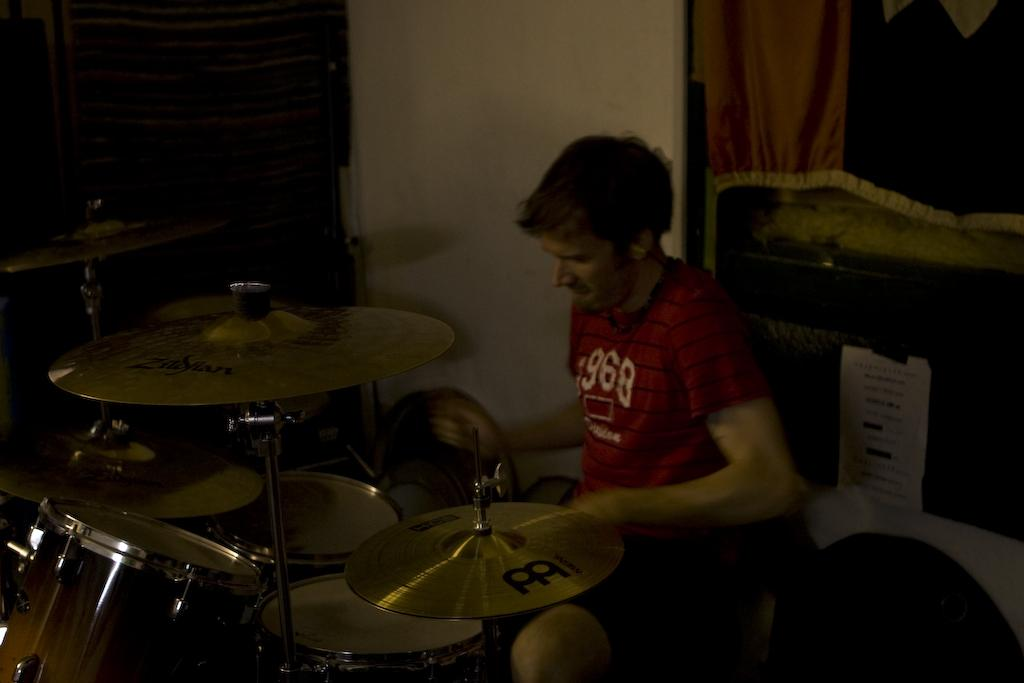Who is the main subject in the image? There is a man in the image. What is the man doing in the image? The man is seated and playing drums. Can you describe any other objects or features in the image? There is a cloth on the window and a paper in the image. What type of cable is being used by the laborer in the image? There is no laborer or cable present in the image. What type of trade is being conducted in the image? There is no trade being conducted in the image; it features a man playing drums. 